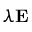Convert formula to latex. <formula><loc_0><loc_0><loc_500><loc_500>\lambda E</formula> 